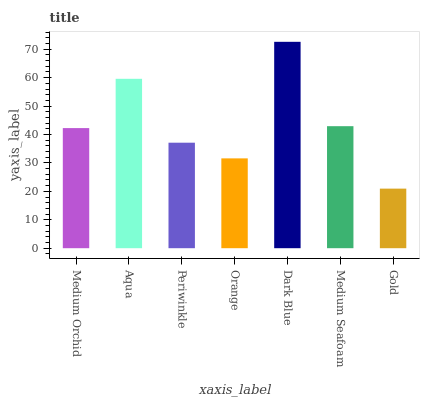Is Aqua the minimum?
Answer yes or no. No. Is Aqua the maximum?
Answer yes or no. No. Is Aqua greater than Medium Orchid?
Answer yes or no. Yes. Is Medium Orchid less than Aqua?
Answer yes or no. Yes. Is Medium Orchid greater than Aqua?
Answer yes or no. No. Is Aqua less than Medium Orchid?
Answer yes or no. No. Is Medium Orchid the high median?
Answer yes or no. Yes. Is Medium Orchid the low median?
Answer yes or no. Yes. Is Orange the high median?
Answer yes or no. No. Is Orange the low median?
Answer yes or no. No. 